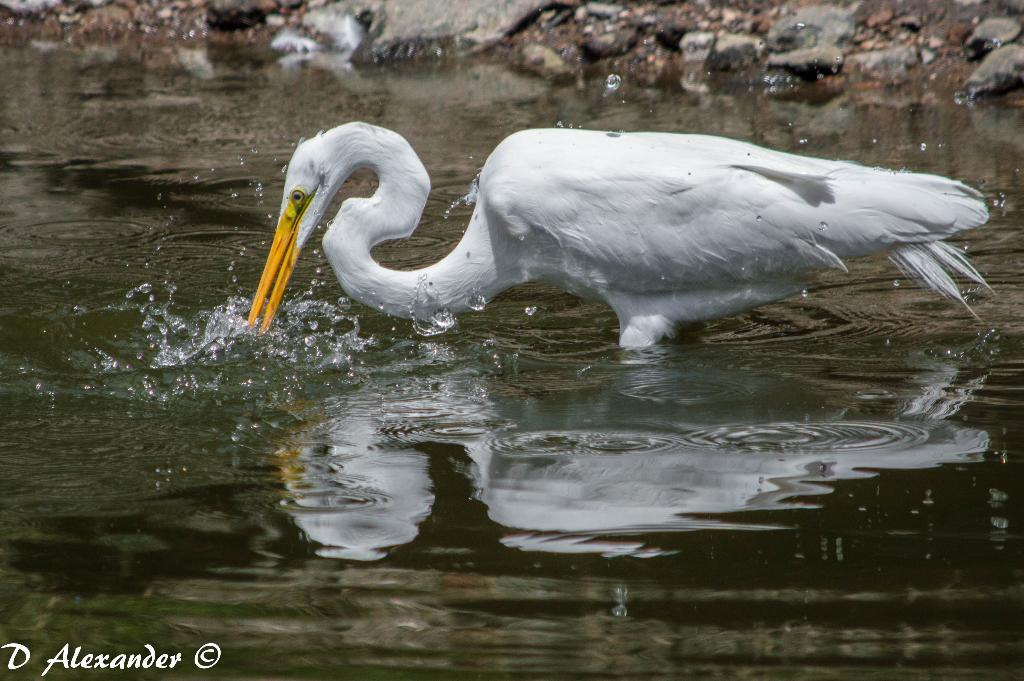What is the main subject of the image? There is a crane in the image. Where is the crane located? The crane is standing in the water. What can be seen behind the crane? There are stones visible behind the crane. What type of sheet is covering the crane in the image? There is no sheet covering the crane in the image; it is standing in the water with no covering. 